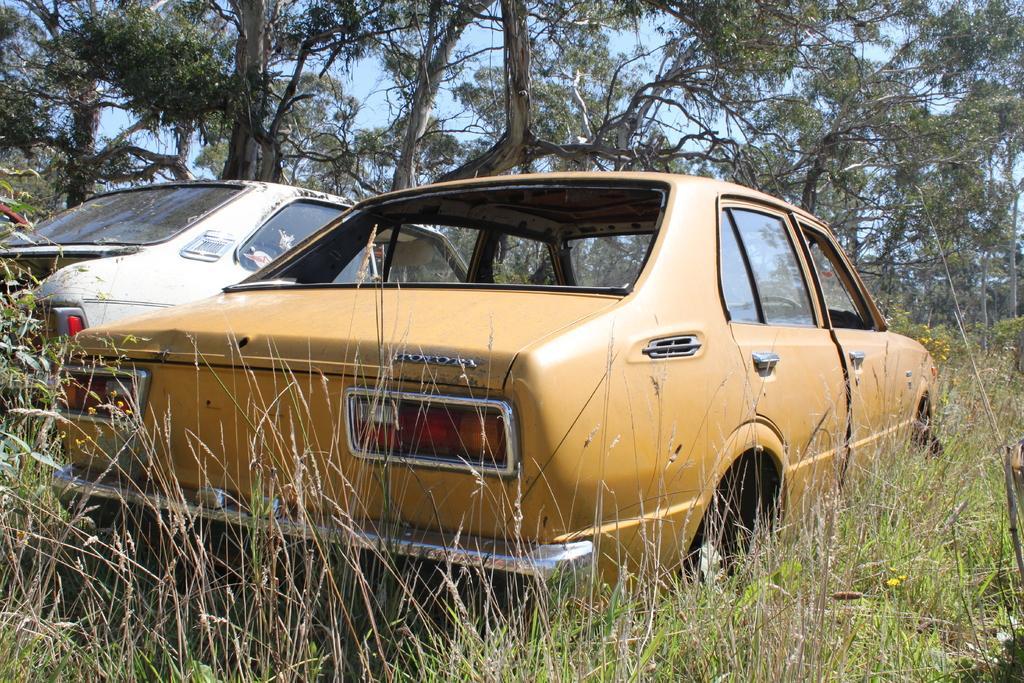Please provide a concise description of this image. There are two vehicles on the ground and in the background we can see trees,sky. 